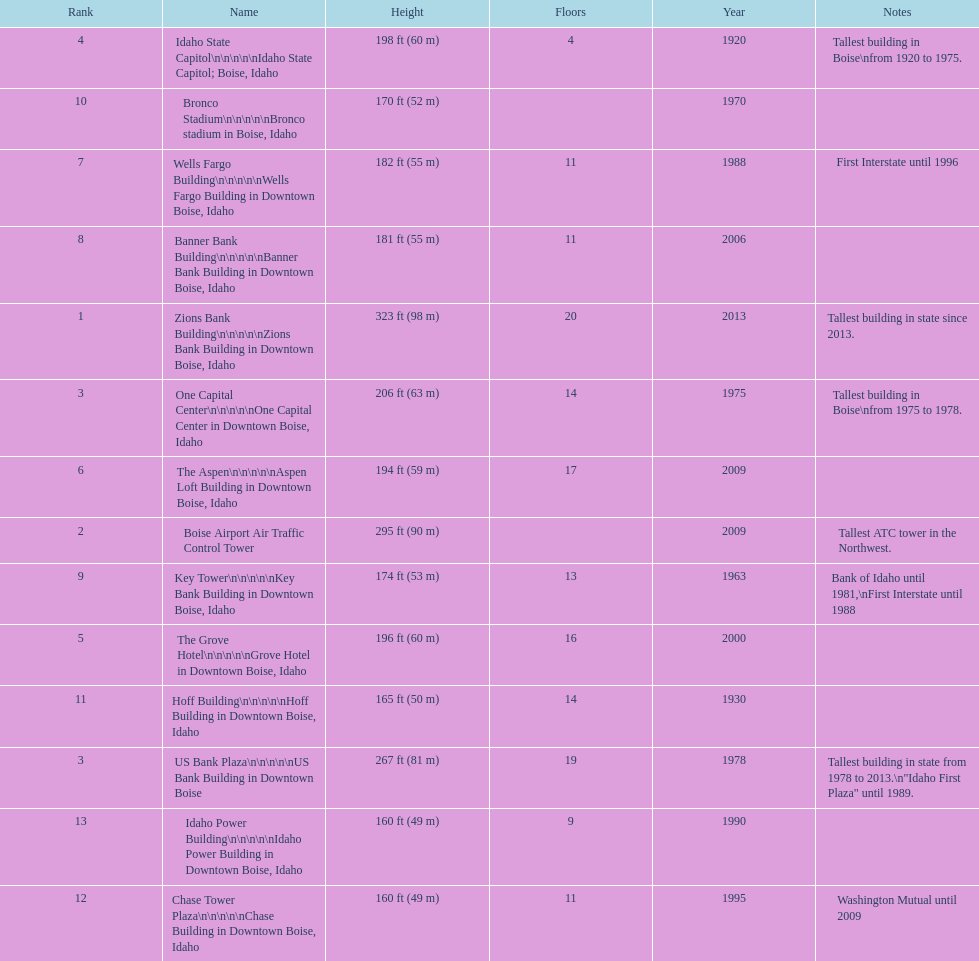What is the name of the last building on this chart? Idaho Power Building. 